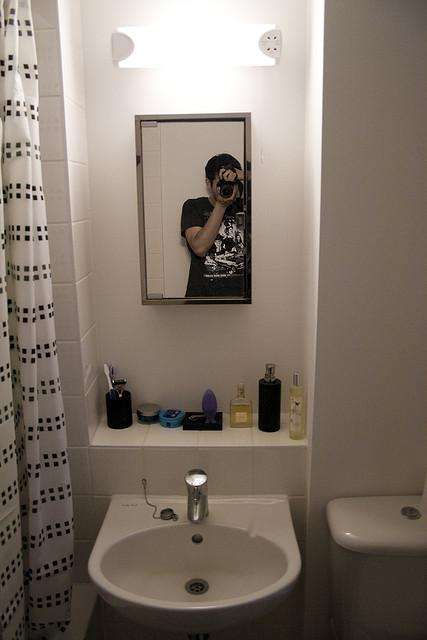A digital single lens reflex is normally known as? Please explain your reasoning. dslr. A digital single lens reflex is briefly known as a dslr 